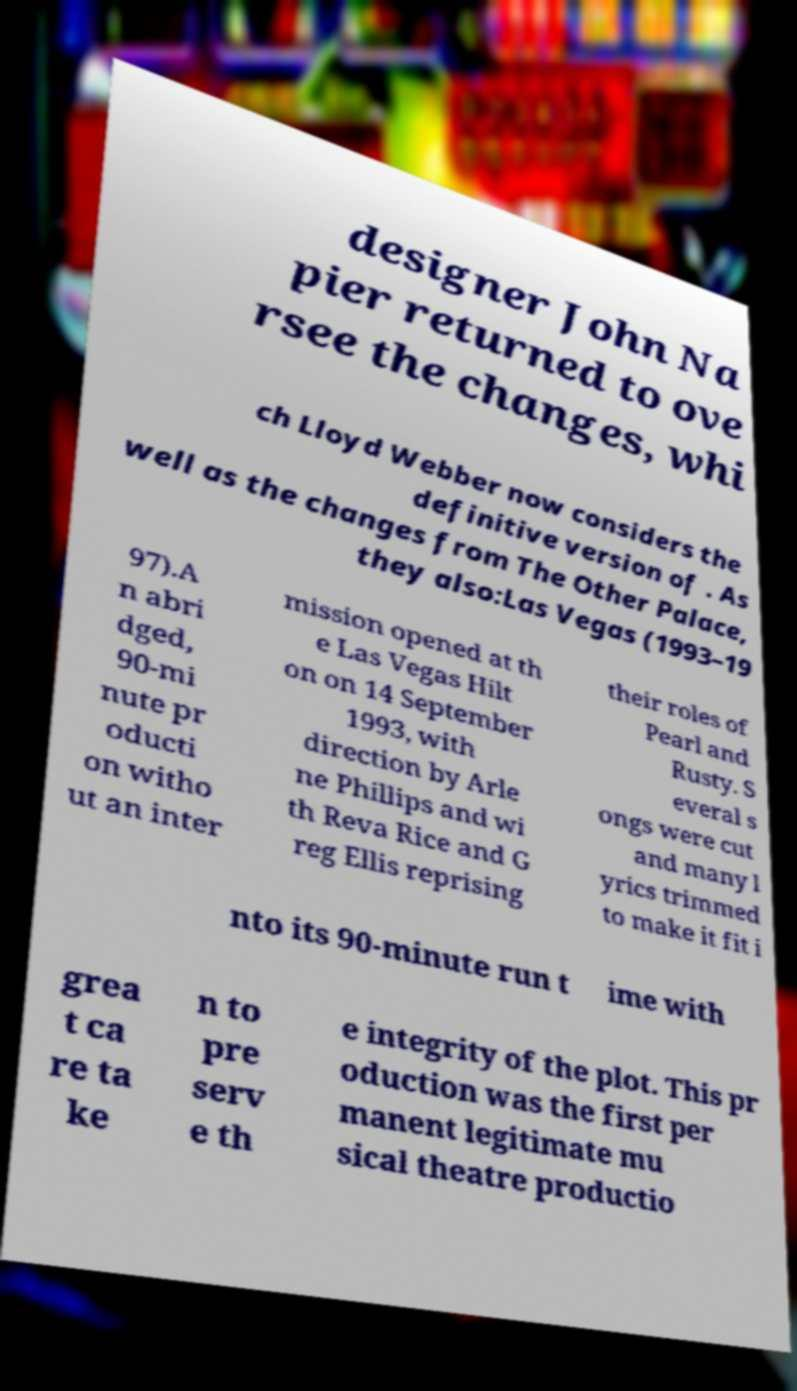Can you accurately transcribe the text from the provided image for me? designer John Na pier returned to ove rsee the changes, whi ch Lloyd Webber now considers the definitive version of . As well as the changes from The Other Palace, they also:Las Vegas (1993–19 97).A n abri dged, 90-mi nute pr oducti on witho ut an inter mission opened at th e Las Vegas Hilt on on 14 September 1993, with direction by Arle ne Phillips and wi th Reva Rice and G reg Ellis reprising their roles of Pearl and Rusty. S everal s ongs were cut and many l yrics trimmed to make it fit i nto its 90-minute run t ime with grea t ca re ta ke n to pre serv e th e integrity of the plot. This pr oduction was the first per manent legitimate mu sical theatre productio 